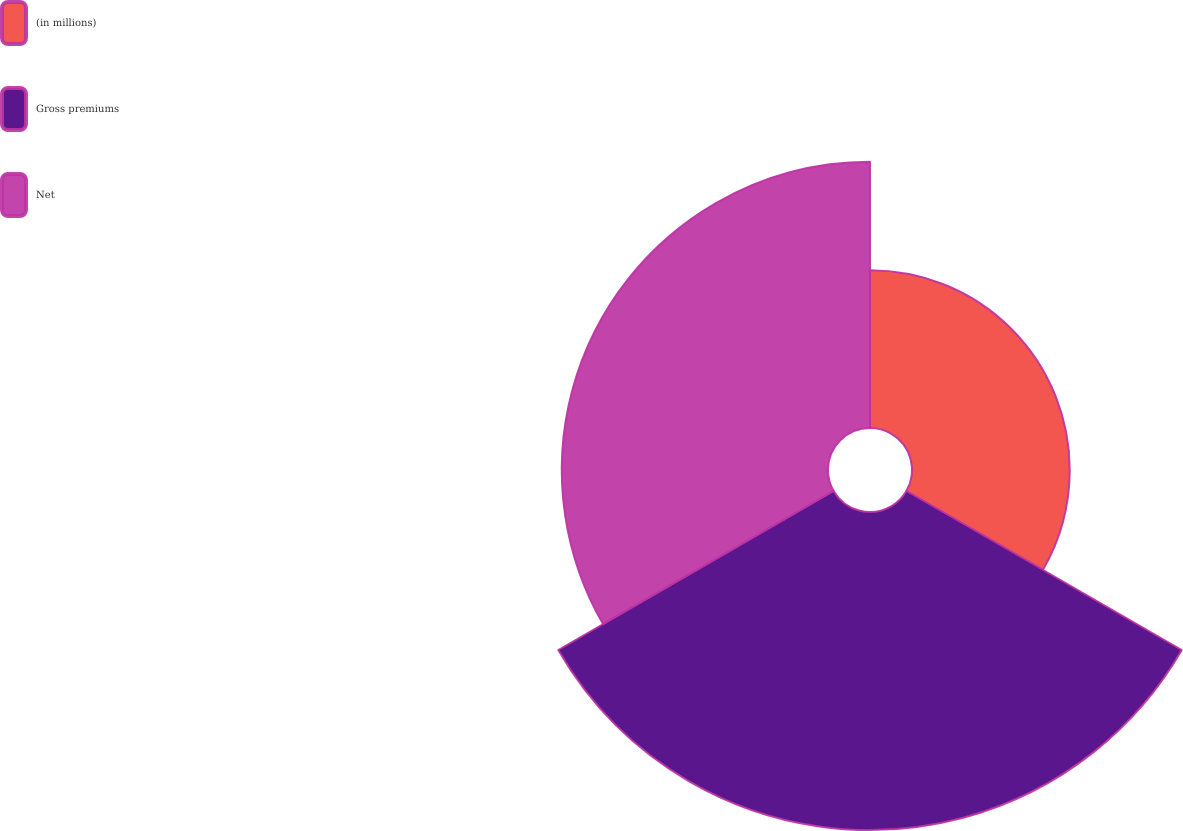Convert chart to OTSL. <chart><loc_0><loc_0><loc_500><loc_500><pie_chart><fcel>(in millions)<fcel>Gross premiums<fcel>Net<nl><fcel>21.26%<fcel>42.86%<fcel>35.88%<nl></chart> 